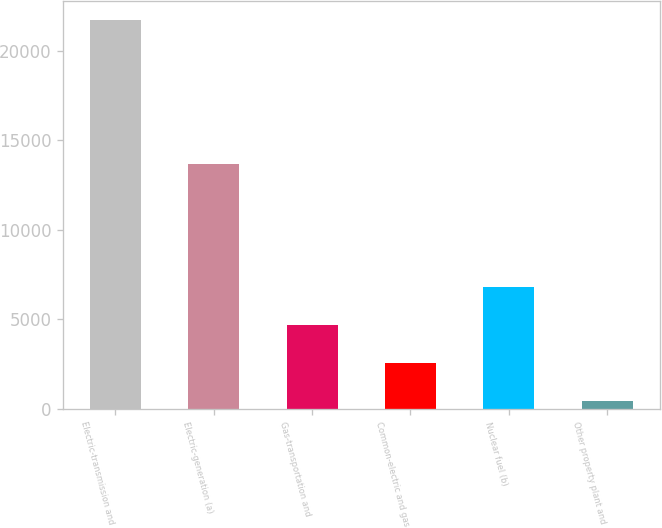Convert chart to OTSL. <chart><loc_0><loc_0><loc_500><loc_500><bar_chart><fcel>Electric-transmission and<fcel>Electric-generation (a)<fcel>Gas-transportation and<fcel>Common-electric and gas<fcel>Nuclear fuel (b)<fcel>Other property plant and<nl><fcel>21716<fcel>13682<fcel>4694.4<fcel>2566.7<fcel>6822.1<fcel>439<nl></chart> 